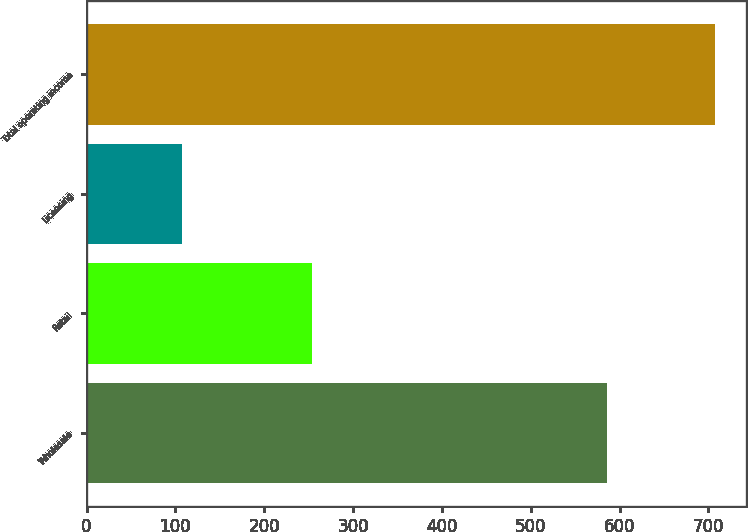Convert chart to OTSL. <chart><loc_0><loc_0><loc_500><loc_500><bar_chart><fcel>Wholesale<fcel>Retail<fcel>Licensing<fcel>Total operating income<nl><fcel>585.3<fcel>254.1<fcel>107.4<fcel>706.9<nl></chart> 